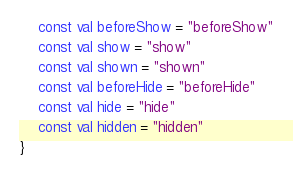Convert code to text. <code><loc_0><loc_0><loc_500><loc_500><_Kotlin_>    const val beforeShow = "beforeShow"
    const val show = "show"
    const val shown = "shown"
    const val beforeHide = "beforeHide"
    const val hide = "hide"
    const val hidden = "hidden"
}
</code> 